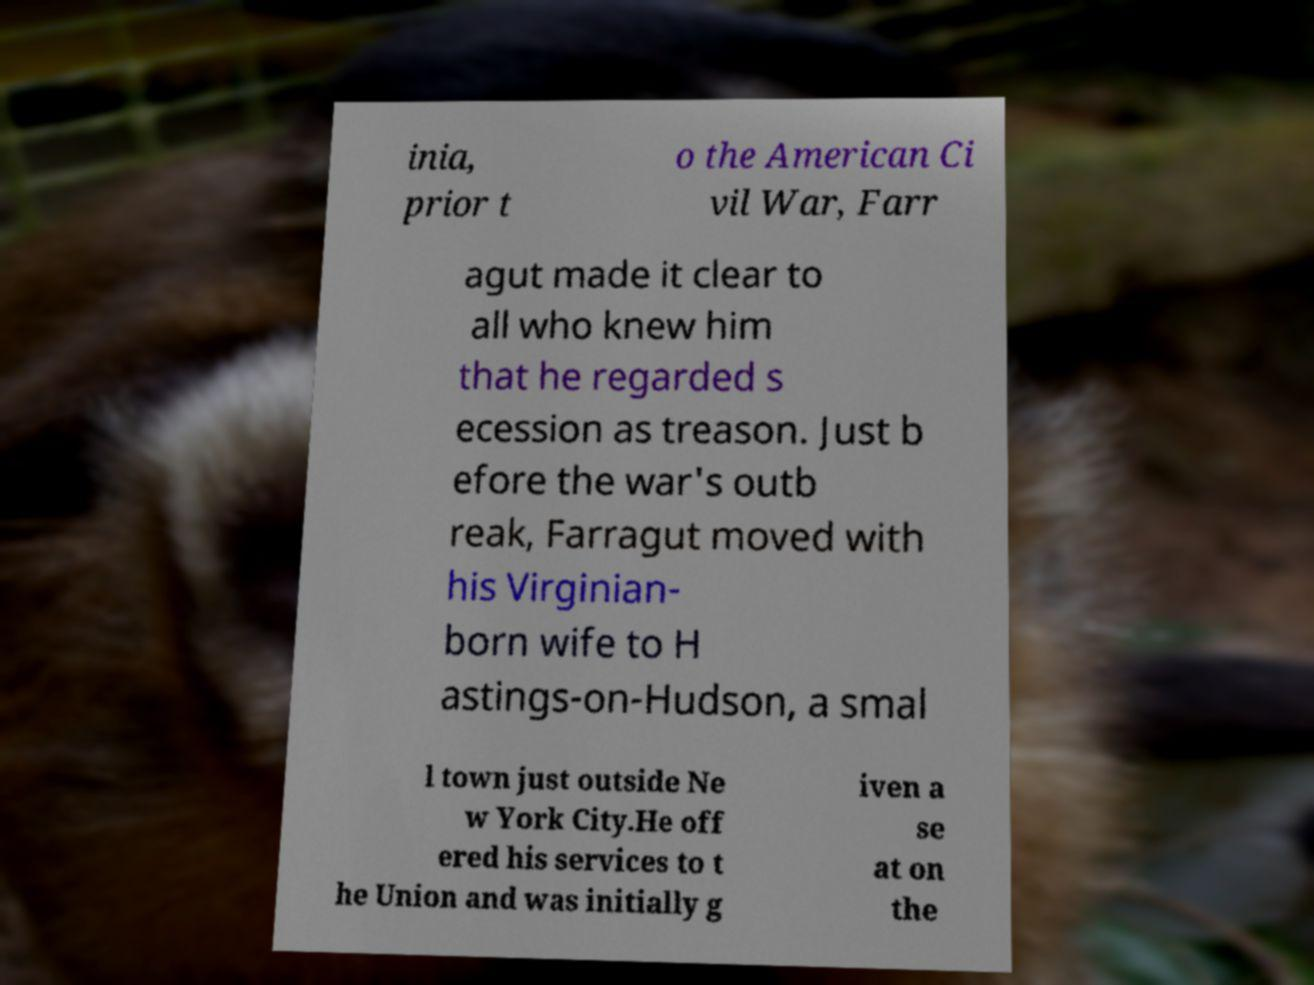I need the written content from this picture converted into text. Can you do that? inia, prior t o the American Ci vil War, Farr agut made it clear to all who knew him that he regarded s ecession as treason. Just b efore the war's outb reak, Farragut moved with his Virginian- born wife to H astings-on-Hudson, a smal l town just outside Ne w York City.He off ered his services to t he Union and was initially g iven a se at on the 